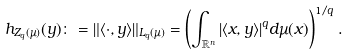Convert formula to latex. <formula><loc_0><loc_0><loc_500><loc_500>h _ { Z _ { q } ( \mu ) } ( y ) \colon = \| \langle \cdot , y \rangle \| _ { L _ { q } ( \mu ) } = \left ( \int _ { { \mathbb { R } } ^ { n } } | \langle x , y \rangle | ^ { q } d \mu ( x ) \right ) ^ { 1 / q } .</formula> 